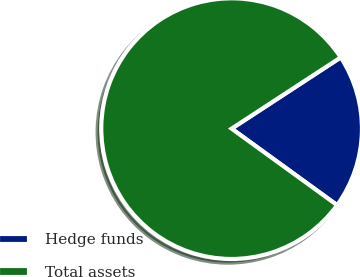Convert chart. <chart><loc_0><loc_0><loc_500><loc_500><pie_chart><fcel>Hedge funds<fcel>Total assets<nl><fcel>19.19%<fcel>80.81%<nl></chart> 